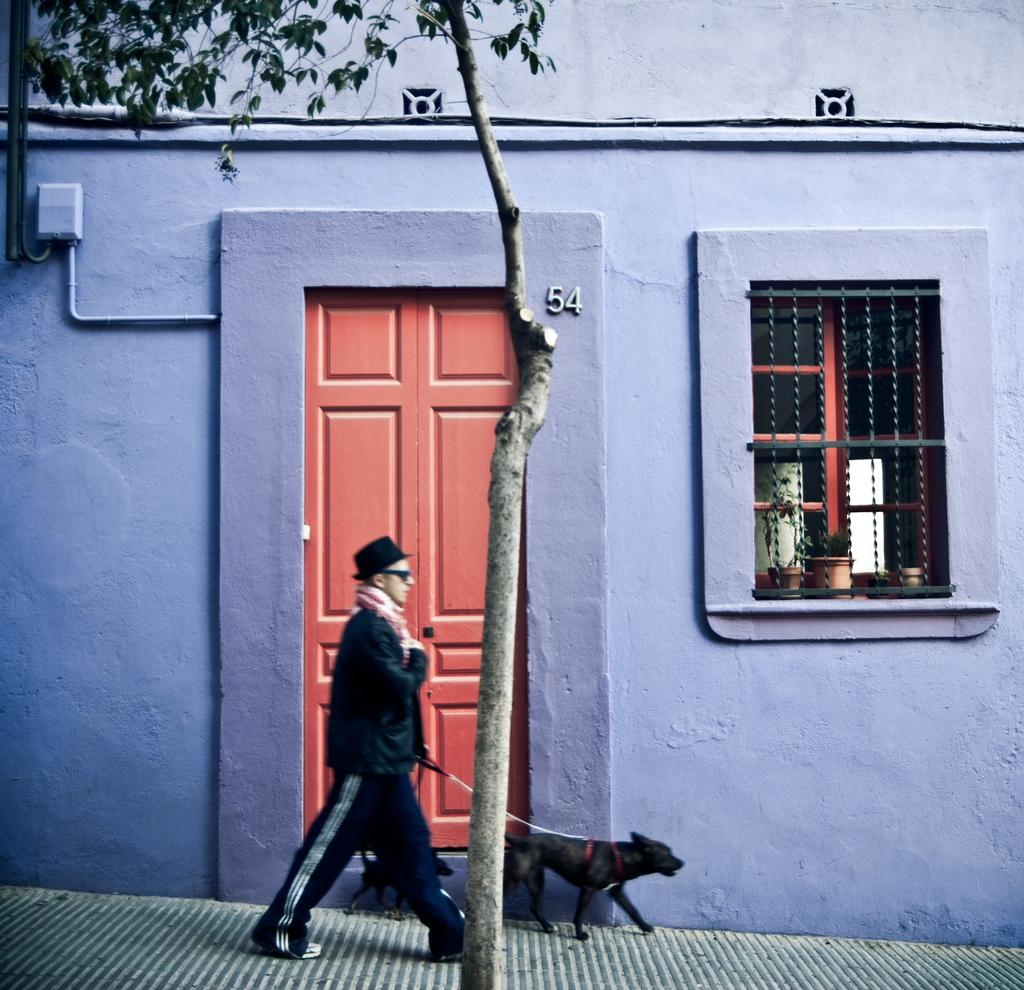What type of structure is visible in the image? There is a building in the image. What features can be seen on the building? The building has a window and a door. What is located near the window? There are plants in front of the window. What is the person in the image doing? A person is walking, as indicated by leg movement. Are there any animals present in the image? Yes, there are dogs beside the person. Where is the shelf located in the image? There is no shelf present in the image. What type of tools can be seen in the hands of the person walking? There is no tool, such as a wrench, visible in the person's hands in the image. 